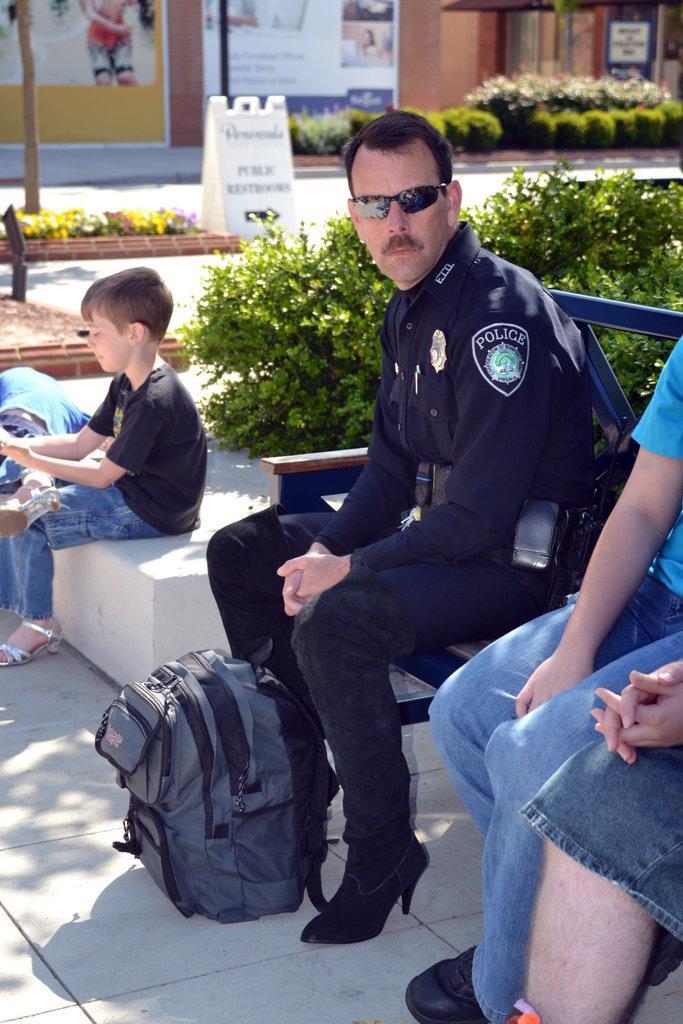Please provide a concise description of this image. In this image I see 3 persons who are sitting on this bench and there is a bag over here and I see a child sitting on this. In the background I see the plants, a board and the buildings. 